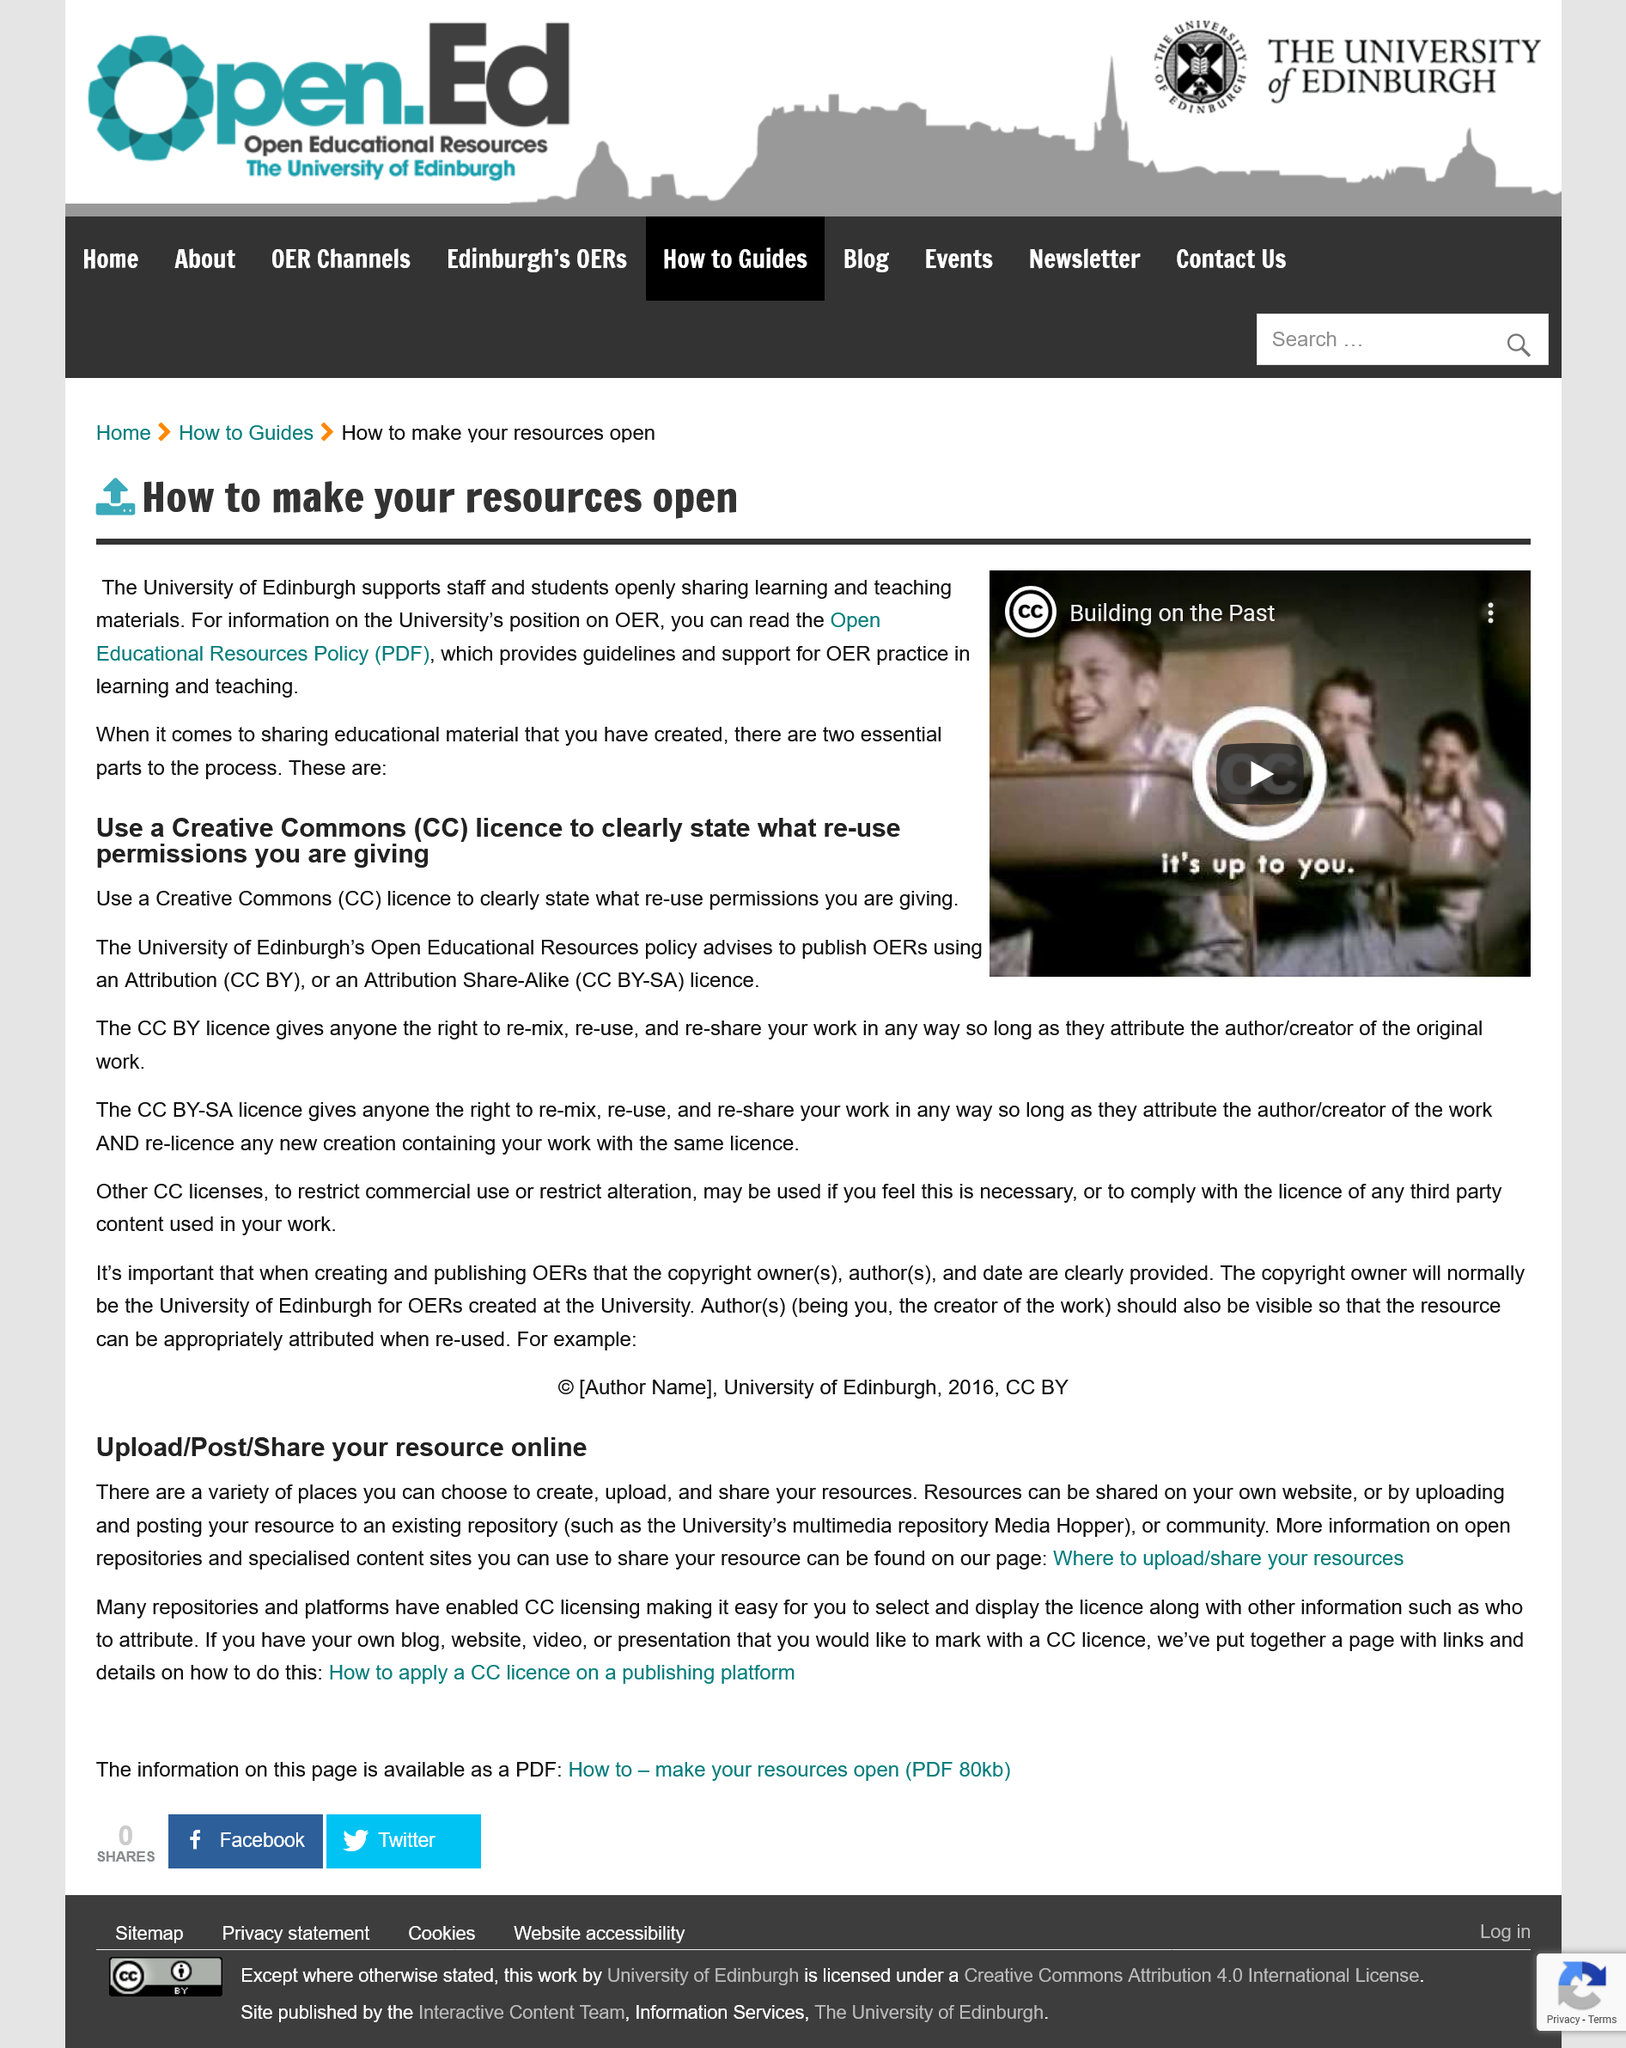Identify some key points in this picture. The CC BY licence allows for the re-mixing, re-use, and re-sharing of a person's work with attribution to the original author/creator, granting them the rights to freely adapt and distribute their work as desired. It is possible to upload and share resources online through the use of your own website or by uploading and posting the resource to an existing repository or community. The University of Edinburgh suggests that the process for openly sharing learning and teaching materials consists of two essential parts. The copyright for OERs created at the University of Edinburgh belongs to the University of Edinburgh. Creative Commons is an organization that provides a set of standardized licenses that allow creators to easily grant permissions for others to use their work. The abbreviation "CC" stands for Creative Commons. 